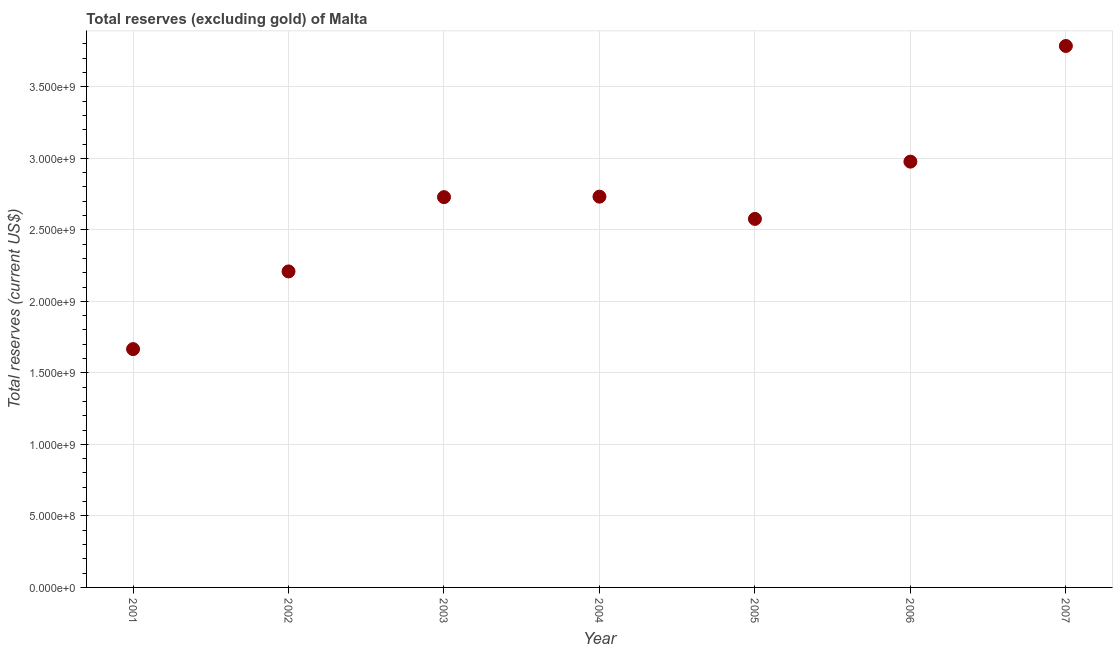What is the total reserves (excluding gold) in 2006?
Your answer should be compact. 2.98e+09. Across all years, what is the maximum total reserves (excluding gold)?
Provide a short and direct response. 3.79e+09. Across all years, what is the minimum total reserves (excluding gold)?
Your response must be concise. 1.67e+09. In which year was the total reserves (excluding gold) maximum?
Your response must be concise. 2007. In which year was the total reserves (excluding gold) minimum?
Provide a short and direct response. 2001. What is the sum of the total reserves (excluding gold)?
Offer a terse response. 1.87e+1. What is the difference between the total reserves (excluding gold) in 2001 and 2004?
Offer a terse response. -1.07e+09. What is the average total reserves (excluding gold) per year?
Ensure brevity in your answer.  2.67e+09. What is the median total reserves (excluding gold)?
Give a very brief answer. 2.73e+09. In how many years, is the total reserves (excluding gold) greater than 2100000000 US$?
Provide a succinct answer. 6. Do a majority of the years between 2001 and 2004 (inclusive) have total reserves (excluding gold) greater than 2400000000 US$?
Your response must be concise. No. What is the ratio of the total reserves (excluding gold) in 2006 to that in 2007?
Provide a short and direct response. 0.79. Is the total reserves (excluding gold) in 2002 less than that in 2005?
Offer a terse response. Yes. Is the difference between the total reserves (excluding gold) in 2001 and 2005 greater than the difference between any two years?
Your answer should be very brief. No. What is the difference between the highest and the second highest total reserves (excluding gold)?
Offer a terse response. 8.09e+08. Is the sum of the total reserves (excluding gold) in 2001 and 2006 greater than the maximum total reserves (excluding gold) across all years?
Offer a very short reply. Yes. What is the difference between the highest and the lowest total reserves (excluding gold)?
Your answer should be very brief. 2.12e+09. Does the total reserves (excluding gold) monotonically increase over the years?
Provide a short and direct response. No. How many dotlines are there?
Your answer should be very brief. 1. Does the graph contain grids?
Provide a short and direct response. Yes. What is the title of the graph?
Give a very brief answer. Total reserves (excluding gold) of Malta. What is the label or title of the X-axis?
Give a very brief answer. Year. What is the label or title of the Y-axis?
Keep it short and to the point. Total reserves (current US$). What is the Total reserves (current US$) in 2001?
Ensure brevity in your answer.  1.67e+09. What is the Total reserves (current US$) in 2002?
Provide a short and direct response. 2.21e+09. What is the Total reserves (current US$) in 2003?
Provide a short and direct response. 2.73e+09. What is the Total reserves (current US$) in 2004?
Ensure brevity in your answer.  2.73e+09. What is the Total reserves (current US$) in 2005?
Make the answer very short. 2.58e+09. What is the Total reserves (current US$) in 2006?
Offer a very short reply. 2.98e+09. What is the Total reserves (current US$) in 2007?
Keep it short and to the point. 3.79e+09. What is the difference between the Total reserves (current US$) in 2001 and 2002?
Keep it short and to the point. -5.43e+08. What is the difference between the Total reserves (current US$) in 2001 and 2003?
Offer a terse response. -1.06e+09. What is the difference between the Total reserves (current US$) in 2001 and 2004?
Your answer should be very brief. -1.07e+09. What is the difference between the Total reserves (current US$) in 2001 and 2005?
Give a very brief answer. -9.10e+08. What is the difference between the Total reserves (current US$) in 2001 and 2006?
Your response must be concise. -1.31e+09. What is the difference between the Total reserves (current US$) in 2001 and 2007?
Provide a short and direct response. -2.12e+09. What is the difference between the Total reserves (current US$) in 2002 and 2003?
Provide a succinct answer. -5.19e+08. What is the difference between the Total reserves (current US$) in 2002 and 2004?
Ensure brevity in your answer.  -5.23e+08. What is the difference between the Total reserves (current US$) in 2002 and 2005?
Offer a terse response. -3.67e+08. What is the difference between the Total reserves (current US$) in 2002 and 2006?
Provide a succinct answer. -7.67e+08. What is the difference between the Total reserves (current US$) in 2002 and 2007?
Your answer should be compact. -1.58e+09. What is the difference between the Total reserves (current US$) in 2003 and 2004?
Offer a terse response. -3.29e+06. What is the difference between the Total reserves (current US$) in 2003 and 2005?
Provide a short and direct response. 1.52e+08. What is the difference between the Total reserves (current US$) in 2003 and 2006?
Your answer should be compact. -2.48e+08. What is the difference between the Total reserves (current US$) in 2003 and 2007?
Ensure brevity in your answer.  -1.06e+09. What is the difference between the Total reserves (current US$) in 2004 and 2005?
Your answer should be very brief. 1.56e+08. What is the difference between the Total reserves (current US$) in 2004 and 2006?
Keep it short and to the point. -2.45e+08. What is the difference between the Total reserves (current US$) in 2004 and 2007?
Your answer should be compact. -1.05e+09. What is the difference between the Total reserves (current US$) in 2005 and 2006?
Provide a short and direct response. -4.00e+08. What is the difference between the Total reserves (current US$) in 2005 and 2007?
Give a very brief answer. -1.21e+09. What is the difference between the Total reserves (current US$) in 2006 and 2007?
Give a very brief answer. -8.09e+08. What is the ratio of the Total reserves (current US$) in 2001 to that in 2002?
Your response must be concise. 0.75. What is the ratio of the Total reserves (current US$) in 2001 to that in 2003?
Keep it short and to the point. 0.61. What is the ratio of the Total reserves (current US$) in 2001 to that in 2004?
Your response must be concise. 0.61. What is the ratio of the Total reserves (current US$) in 2001 to that in 2005?
Give a very brief answer. 0.65. What is the ratio of the Total reserves (current US$) in 2001 to that in 2006?
Ensure brevity in your answer.  0.56. What is the ratio of the Total reserves (current US$) in 2001 to that in 2007?
Your answer should be compact. 0.44. What is the ratio of the Total reserves (current US$) in 2002 to that in 2003?
Offer a terse response. 0.81. What is the ratio of the Total reserves (current US$) in 2002 to that in 2004?
Offer a very short reply. 0.81. What is the ratio of the Total reserves (current US$) in 2002 to that in 2005?
Your response must be concise. 0.86. What is the ratio of the Total reserves (current US$) in 2002 to that in 2006?
Your response must be concise. 0.74. What is the ratio of the Total reserves (current US$) in 2002 to that in 2007?
Provide a short and direct response. 0.58. What is the ratio of the Total reserves (current US$) in 2003 to that in 2004?
Ensure brevity in your answer.  1. What is the ratio of the Total reserves (current US$) in 2003 to that in 2005?
Give a very brief answer. 1.06. What is the ratio of the Total reserves (current US$) in 2003 to that in 2006?
Offer a very short reply. 0.92. What is the ratio of the Total reserves (current US$) in 2003 to that in 2007?
Ensure brevity in your answer.  0.72. What is the ratio of the Total reserves (current US$) in 2004 to that in 2005?
Your answer should be compact. 1.06. What is the ratio of the Total reserves (current US$) in 2004 to that in 2006?
Provide a short and direct response. 0.92. What is the ratio of the Total reserves (current US$) in 2004 to that in 2007?
Provide a short and direct response. 0.72. What is the ratio of the Total reserves (current US$) in 2005 to that in 2006?
Your response must be concise. 0.87. What is the ratio of the Total reserves (current US$) in 2005 to that in 2007?
Offer a very short reply. 0.68. What is the ratio of the Total reserves (current US$) in 2006 to that in 2007?
Keep it short and to the point. 0.79. 